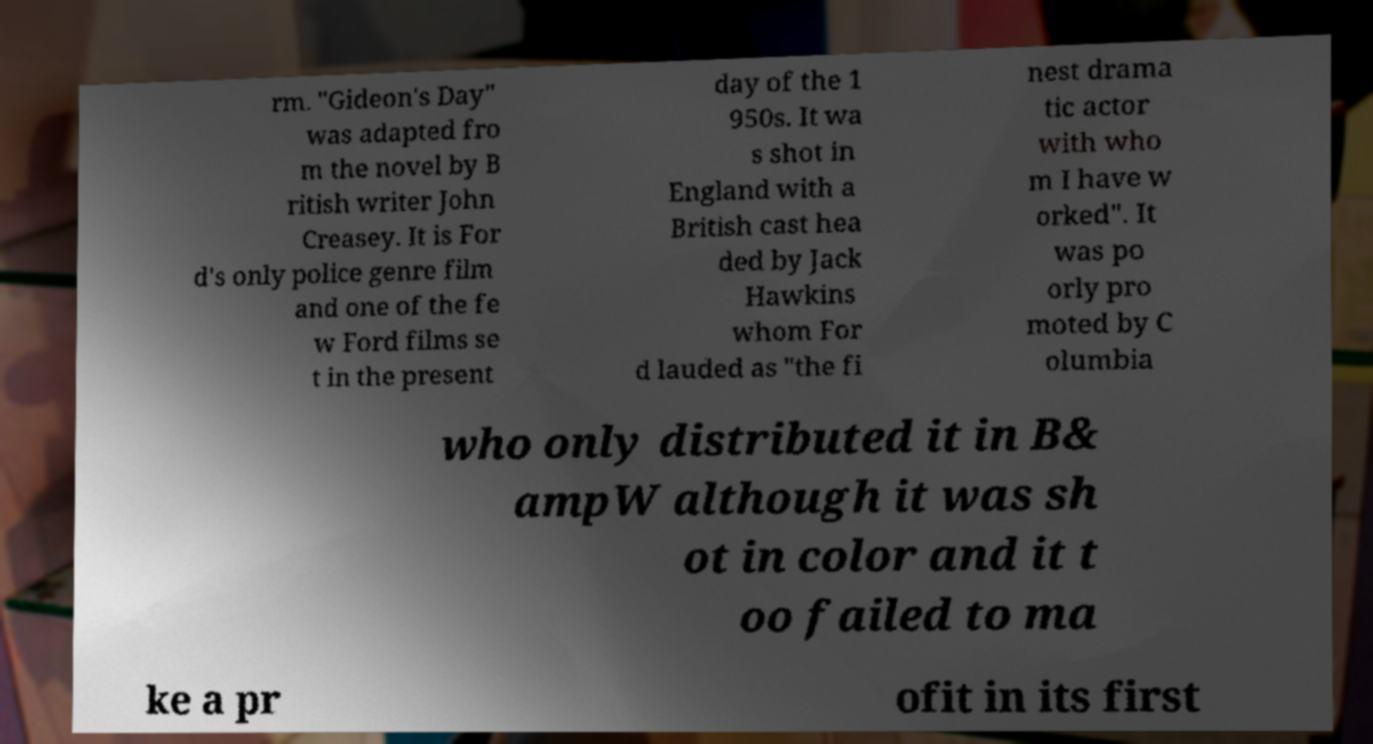Please read and relay the text visible in this image. What does it say? rm. "Gideon's Day" was adapted fro m the novel by B ritish writer John Creasey. It is For d's only police genre film and one of the fe w Ford films se t in the present day of the 1 950s. It wa s shot in England with a British cast hea ded by Jack Hawkins whom For d lauded as "the fi nest drama tic actor with who m I have w orked". It was po orly pro moted by C olumbia who only distributed it in B& ampW although it was sh ot in color and it t oo failed to ma ke a pr ofit in its first 